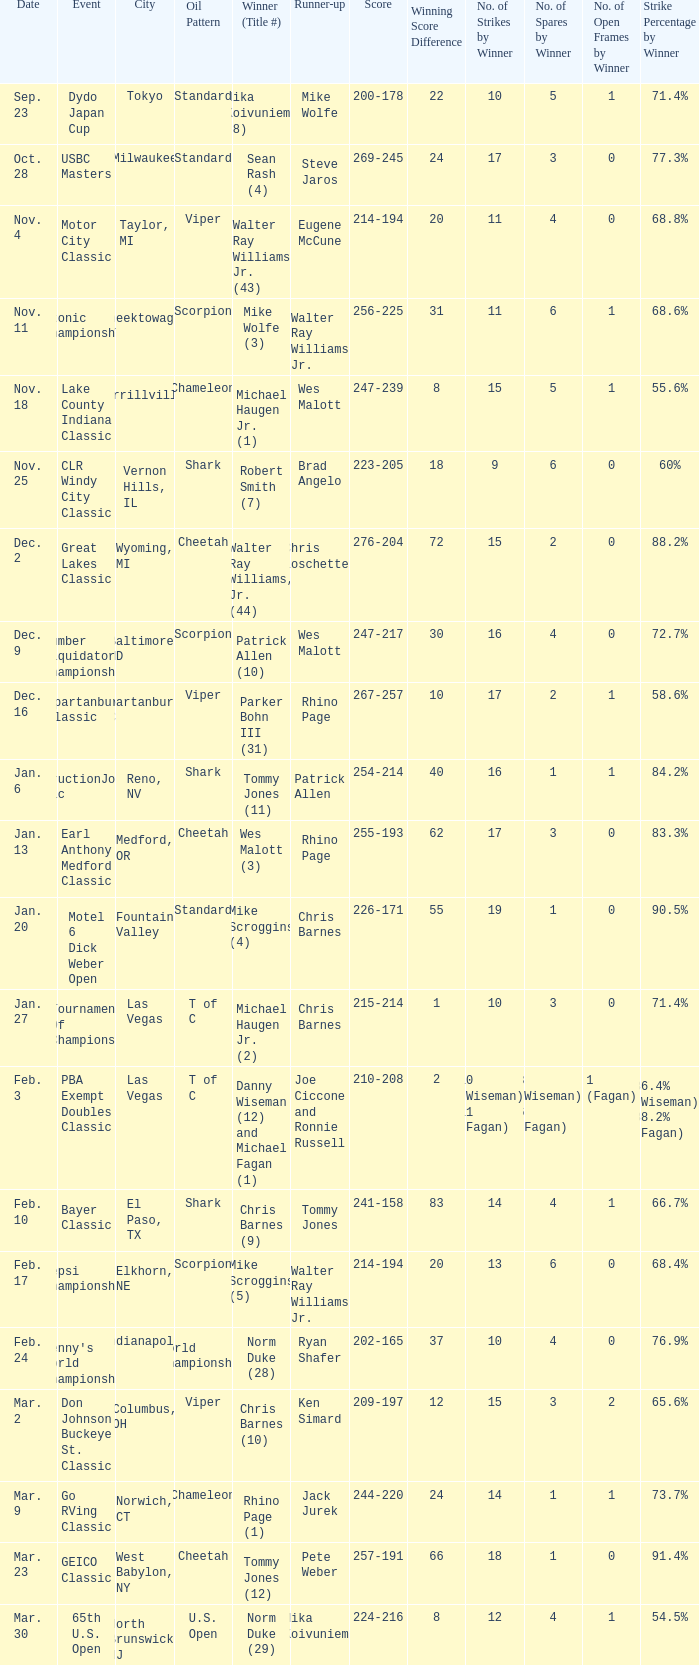Name the Date when has  robert smith (7)? Nov. 25. Could you parse the entire table as a dict? {'header': ['Date', 'Event', 'City', 'Oil Pattern', 'Winner (Title #)', 'Runner-up', 'Score', 'Winning Score Difference', 'No. of Strikes by Winner', 'No. of Spares by Winner', 'No. of Open Frames by Winner', 'Strike Percentage by Winner'], 'rows': [['Sep. 23', 'Dydo Japan Cup', 'Tokyo', 'Standard', 'Mika Koivuniemi (8)', 'Mike Wolfe', '200-178', '22', '10', '5', '1', '71.4%'], ['Oct. 28', 'USBC Masters', 'Milwaukee', 'Standard', 'Sean Rash (4)', 'Steve Jaros', '269-245', '24', '17', '3', '0', '77.3%'], ['Nov. 4', 'Motor City Classic', 'Taylor, MI', 'Viper', 'Walter Ray Williams Jr. (43)', 'Eugene McCune', '214-194', '20', '11', '4', '0', '68.8%'], ['Nov. 11', 'Etonic Championship', 'Cheektowaga, NY', 'Scorpion', 'Mike Wolfe (3)', 'Walter Ray Williams Jr.', '256-225', '31', '11', '6', '1', '68.6%'], ['Nov. 18', 'Lake County Indiana Classic', 'Merrillville, IN', 'Chameleon', 'Michael Haugen Jr. (1)', 'Wes Malott', '247-239', '8', '15', '5', '1', '55.6%'], ['Nov. 25', 'CLR Windy City Classic', 'Vernon Hills, IL', 'Shark', 'Robert Smith (7)', 'Brad Angelo', '223-205', '18', '9', '6', '0', '60%'], ['Dec. 2', 'Great Lakes Classic', 'Wyoming, MI', 'Cheetah', 'Walter Ray Williams, Jr. (44)', 'Chris Loschetter', '276-204', '72', '15', '2', '0', '88.2%'], ['Dec. 9', 'Lumber Liquidators Championship', 'Baltimore, MD', 'Scorpion', 'Patrick Allen (10)', 'Wes Malott', '247-217', '30', '16', '4', '0', '72.7%'], ['Dec. 16', 'Spartanburg Classic', 'Spartanburg, SC', 'Viper', 'Parker Bohn III (31)', 'Rhino Page', '267-257', '10', '17', '2', '1', '58.6%'], ['Jan. 6', 'ConstructionJobs.com Classic', 'Reno, NV', 'Shark', 'Tommy Jones (11)', 'Patrick Allen', '254-214', '40', '16', '1', '1', '84.2%'], ['Jan. 13', 'Earl Anthony Medford Classic', 'Medford, OR', 'Cheetah', 'Wes Malott (3)', 'Rhino Page', '255-193', '62', '17', '3', '0', '83.3%'], ['Jan. 20', 'Motel 6 Dick Weber Open', 'Fountain Valley', 'Standard', 'Mike Scroggins (4)', 'Chris Barnes', '226-171', '55', '19', '1', '0', '90.5%'], ['Jan. 27', 'Tournament Of Champions', 'Las Vegas', 'T of C', 'Michael Haugen Jr. (2)', 'Chris Barnes', '215-214', '1', '10', '3', '0', '71.4%'], ['Feb. 3', 'PBA Exempt Doubles Classic', 'Las Vegas', 'T of C', 'Danny Wiseman (12) and Michael Fagan (1)', 'Joe Ciccone and Ronnie Russell', '210-208', '2', '10 (Wiseman), 11 (Fagan)', '3 (Wiseman), 6 (Fagan)', '1 (Fagan)', '86.4% (Wiseman), 88.2% (Fagan)'], ['Feb. 10', 'Bayer Classic', 'El Paso, TX', 'Shark', 'Chris Barnes (9)', 'Tommy Jones', '241-158', '83', '14', '4', '1', '66.7%'], ['Feb. 17', 'Pepsi Championship', 'Elkhorn, NE', 'Scorpion', 'Mike Scroggins (5)', 'Walter Ray Williams Jr.', '214-194', '20', '13', '6', '0', '68.4%'], ['Feb. 24', "Denny's World Championship", 'Indianapolis', 'World Championship', 'Norm Duke (28)', 'Ryan Shafer', '202-165', '37', '10', '4', '0', '76.9%'], ['Mar. 2', 'Don Johnson Buckeye St. Classic', 'Columbus, OH', 'Viper', 'Chris Barnes (10)', 'Ken Simard', '209-197', '12', '15', '3', '2', '65.6%'], ['Mar. 9', 'Go RVing Classic', 'Norwich, CT', 'Chameleon', 'Rhino Page (1)', 'Jack Jurek', '244-220', '24', '14', '1', '1', '73.7%'], ['Mar. 23', 'GEICO Classic', 'West Babylon, NY', 'Cheetah', 'Tommy Jones (12)', 'Pete Weber', '257-191', '66', '18', '1', '0', '91.4%'], ['Mar. 30', '65th U.S. Open', 'North Brunswick, NJ', 'U.S. Open', 'Norm Duke (29)', 'Mika Koivuniemi', '224-216', '8', '12', '4', '1', '54.5%']]} 